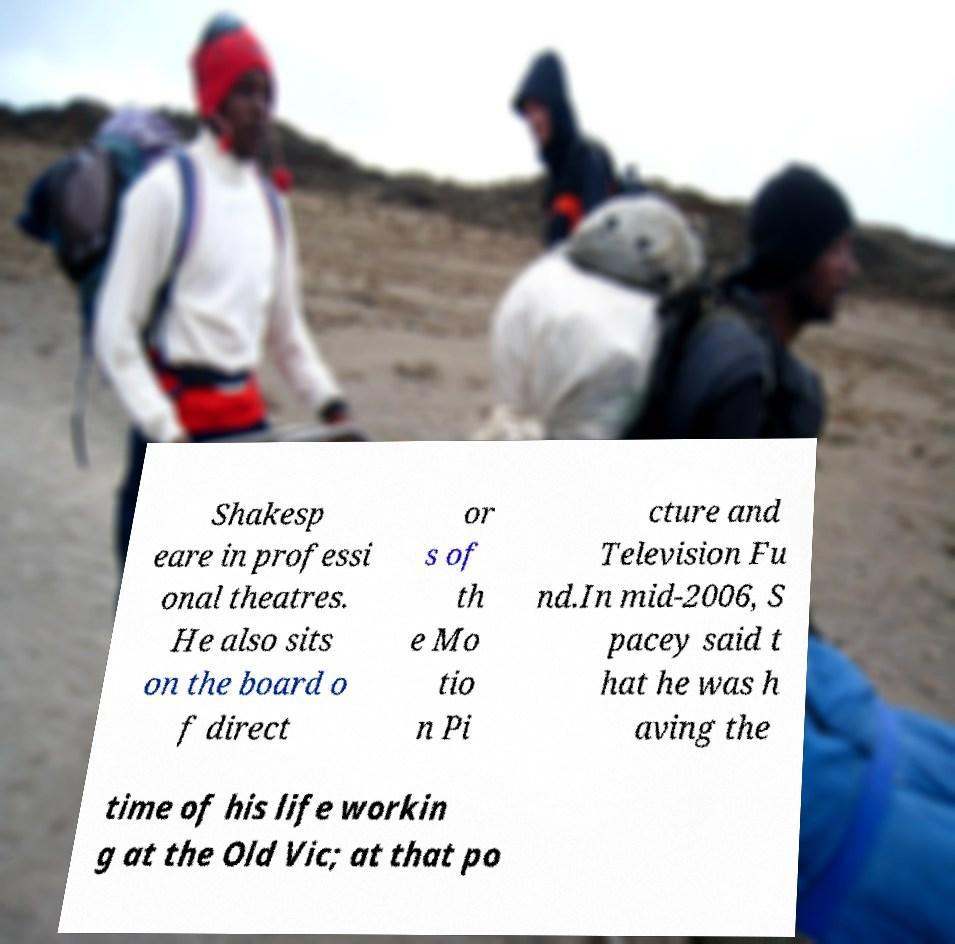Please read and relay the text visible in this image. What does it say? Shakesp eare in professi onal theatres. He also sits on the board o f direct or s of th e Mo tio n Pi cture and Television Fu nd.In mid-2006, S pacey said t hat he was h aving the time of his life workin g at the Old Vic; at that po 